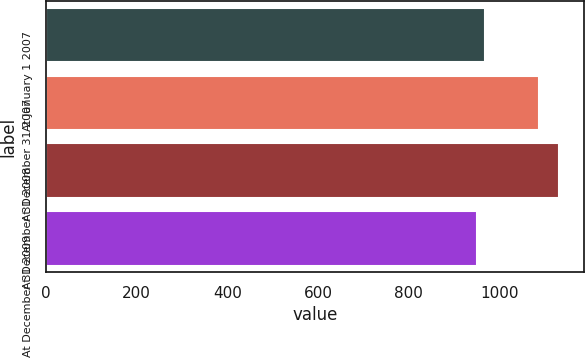Convert chart to OTSL. <chart><loc_0><loc_0><loc_500><loc_500><bar_chart><fcel>At January 1 2007<fcel>At December 31 2007<fcel>At December 31 2008<fcel>At December 31 2009<nl><fcel>968.1<fcel>1088<fcel>1131<fcel>950<nl></chart> 